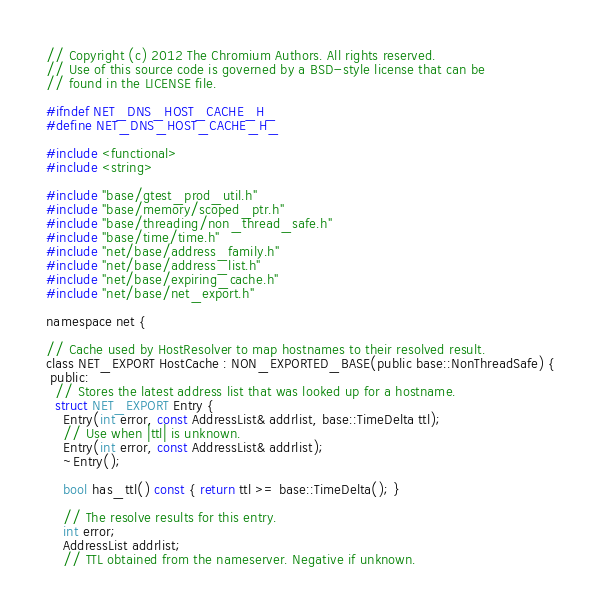<code> <loc_0><loc_0><loc_500><loc_500><_C_>// Copyright (c) 2012 The Chromium Authors. All rights reserved.
// Use of this source code is governed by a BSD-style license that can be
// found in the LICENSE file.

#ifndef NET_DNS_HOST_CACHE_H_
#define NET_DNS_HOST_CACHE_H_

#include <functional>
#include <string>

#include "base/gtest_prod_util.h"
#include "base/memory/scoped_ptr.h"
#include "base/threading/non_thread_safe.h"
#include "base/time/time.h"
#include "net/base/address_family.h"
#include "net/base/address_list.h"
#include "net/base/expiring_cache.h"
#include "net/base/net_export.h"

namespace net {

// Cache used by HostResolver to map hostnames to their resolved result.
class NET_EXPORT HostCache : NON_EXPORTED_BASE(public base::NonThreadSafe) {
 public:
  // Stores the latest address list that was looked up for a hostname.
  struct NET_EXPORT Entry {
    Entry(int error, const AddressList& addrlist, base::TimeDelta ttl);
    // Use when |ttl| is unknown.
    Entry(int error, const AddressList& addrlist);
    ~Entry();

    bool has_ttl() const { return ttl >= base::TimeDelta(); }

    // The resolve results for this entry.
    int error;
    AddressList addrlist;
    // TTL obtained from the nameserver. Negative if unknown.</code> 